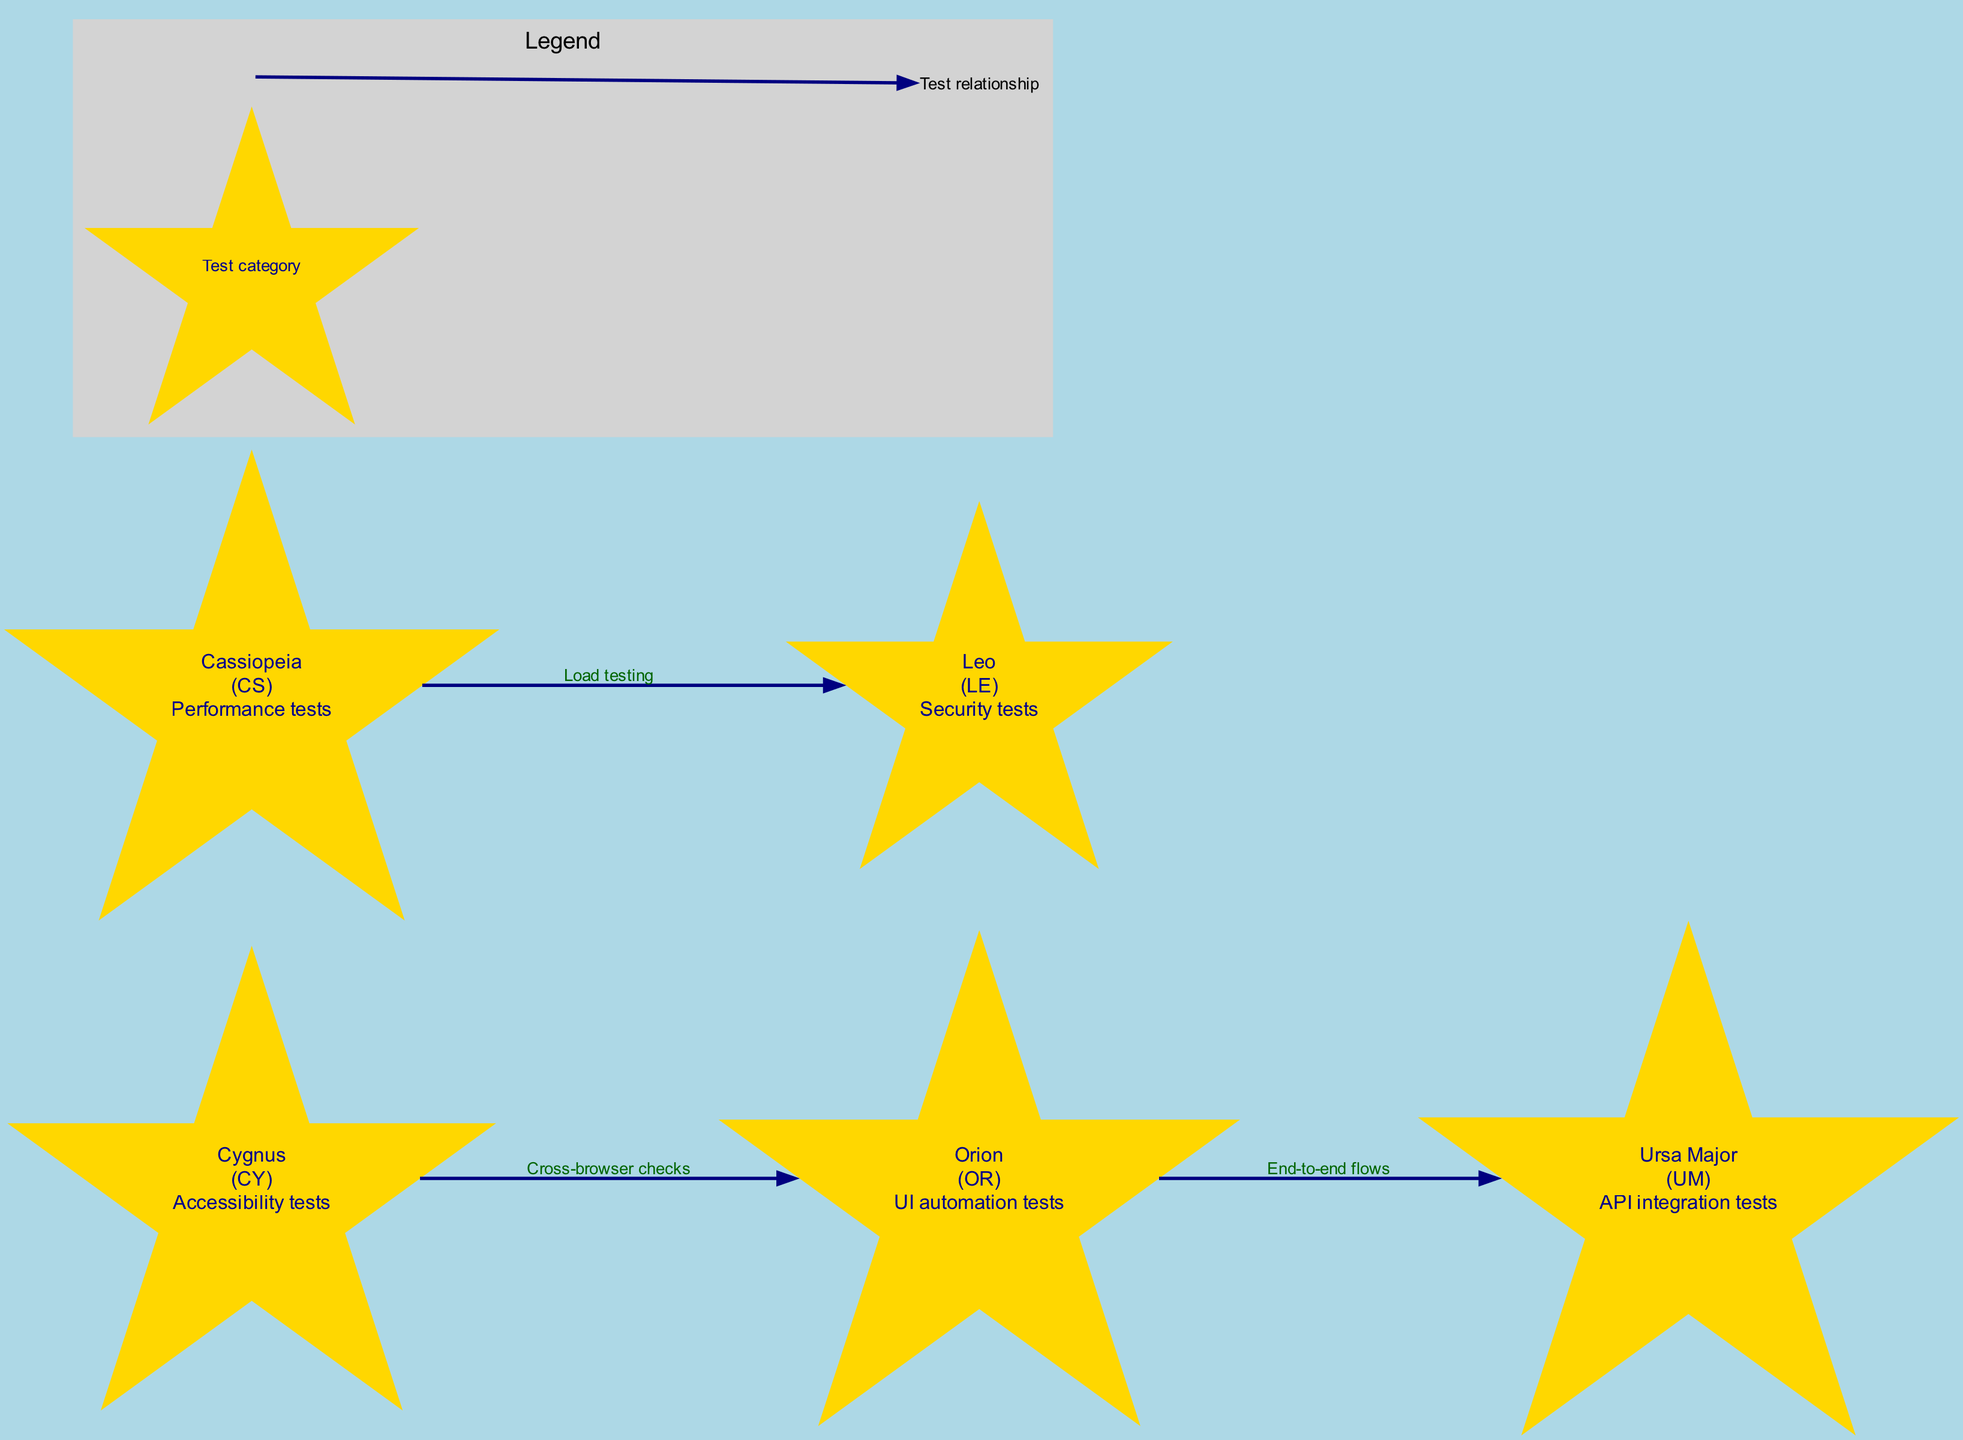What are the test case prefixes for Orion? According to the diagram, Orion has the test case prefix "OR" as indicated in its label.
Answer: OR How many constellations are in the diagram? The diagram includes five constellations: Orion, Ursa Major, Cassiopeia, Leo, and Cygnus. Therefore, by counting them, we find the total is five.
Answer: 5 What type of tests does Cassiopeia represent? The diagram shows that Cassiopeia is associated with "Performance tests," which is found in the label of the constellation.
Answer: Performance tests Which constellation is connected to Orion? The diagram reveals that both Ursa Major and Cygnus are connected to Orion. By reviewing the connections, we can affirm that Ursa Major and Cygnus connect to Orion.
Answer: Ursa Major, Cygnus What is the relationship labeled between Cassiopeia and Leo? According to the connections labeled in the diagram, the relationship between Cassiopeia and Leo is described as "Load testing."
Answer: Load testing What is the significance of the symbol representing constellations? In the legend, it states that the symbol of a star represents "Test category," indicating what constitutes a category of tests.
Answer: Test category Which constellation indicates security tests? From the diagram, Leo is identified as representing "Security tests," as per its description in the constellation label.
Answer: Leo How many edges are present in the diagram? By analyzing the connections, the diagram demonstrates three edges connecting the constellations, namely Orion to Ursa Major, Cassiopeia to Leo, and Cygnus to Orion.
Answer: 3 What does the line symbol represent in the legend? The legend in the diagram clarifies that the line symbol signifies "Test relationship," indicating how constellations relate to one another in terms of tests.
Answer: Test relationship Which constellation has an accessible test type? According to the diagram, Cygnus represents "Accessibility tests" as specified in the corresponding description label.
Answer: Cygnus 